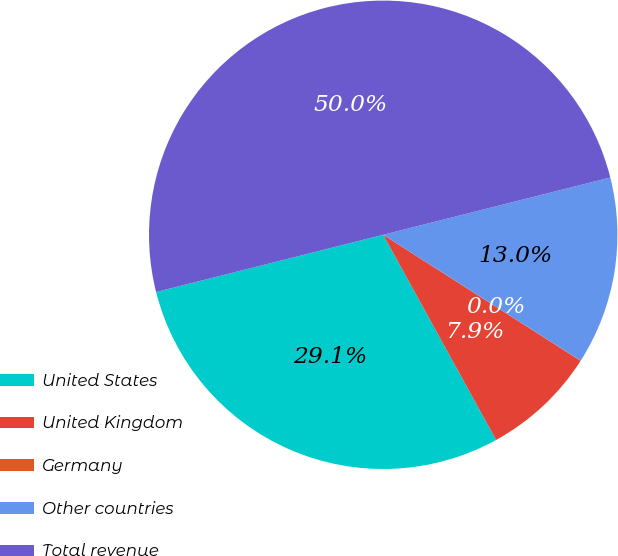Convert chart to OTSL. <chart><loc_0><loc_0><loc_500><loc_500><pie_chart><fcel>United States<fcel>United Kingdom<fcel>Germany<fcel>Other countries<fcel>Total revenue<nl><fcel>29.08%<fcel>7.95%<fcel>0.01%<fcel>12.97%<fcel>50.0%<nl></chart> 